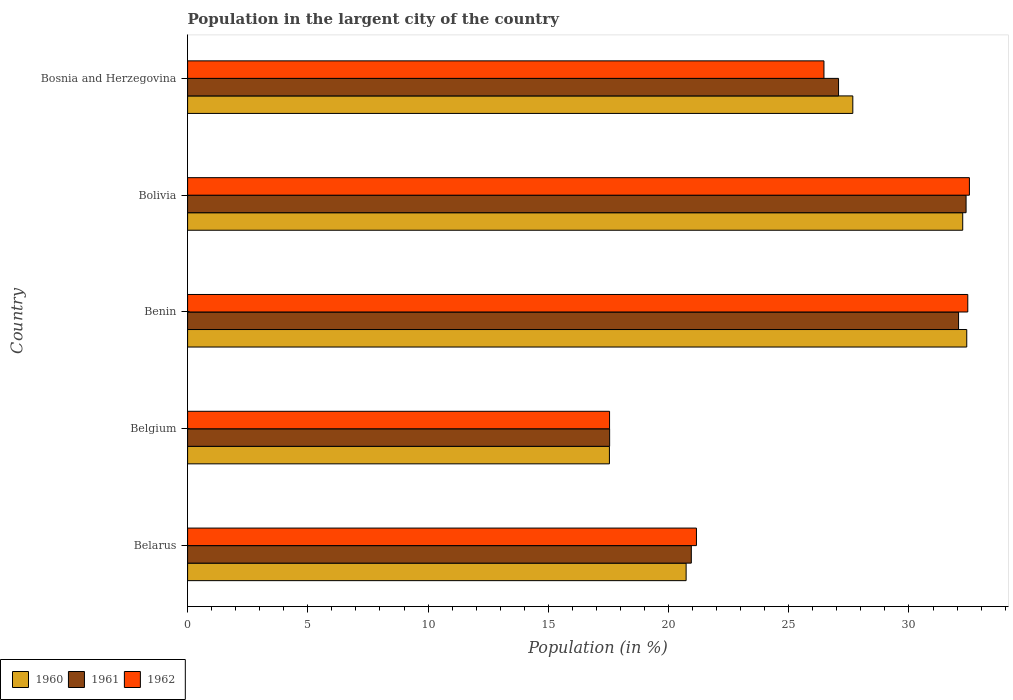How many groups of bars are there?
Provide a short and direct response. 5. Are the number of bars on each tick of the Y-axis equal?
Ensure brevity in your answer.  Yes. What is the label of the 4th group of bars from the top?
Make the answer very short. Belgium. In how many cases, is the number of bars for a given country not equal to the number of legend labels?
Provide a succinct answer. 0. What is the percentage of population in the largent city in 1960 in Belarus?
Provide a short and direct response. 20.73. Across all countries, what is the maximum percentage of population in the largent city in 1962?
Provide a short and direct response. 32.51. Across all countries, what is the minimum percentage of population in the largent city in 1960?
Your response must be concise. 17.54. In which country was the percentage of population in the largent city in 1961 minimum?
Give a very brief answer. Belgium. What is the total percentage of population in the largent city in 1960 in the graph?
Your answer should be very brief. 130.58. What is the difference between the percentage of population in the largent city in 1962 in Belgium and that in Bolivia?
Provide a short and direct response. -14.96. What is the difference between the percentage of population in the largent city in 1960 in Bosnia and Herzegovina and the percentage of population in the largent city in 1961 in Belgium?
Provide a short and direct response. 10.11. What is the average percentage of population in the largent city in 1960 per country?
Your answer should be compact. 26.12. What is the difference between the percentage of population in the largent city in 1960 and percentage of population in the largent city in 1962 in Belarus?
Your response must be concise. -0.43. In how many countries, is the percentage of population in the largent city in 1960 greater than 32 %?
Provide a short and direct response. 2. What is the ratio of the percentage of population in the largent city in 1962 in Benin to that in Bosnia and Herzegovina?
Your answer should be very brief. 1.23. What is the difference between the highest and the second highest percentage of population in the largent city in 1960?
Provide a short and direct response. 0.17. What is the difference between the highest and the lowest percentage of population in the largent city in 1962?
Ensure brevity in your answer.  14.96. In how many countries, is the percentage of population in the largent city in 1962 greater than the average percentage of population in the largent city in 1962 taken over all countries?
Provide a short and direct response. 3. What does the 2nd bar from the top in Bosnia and Herzegovina represents?
Keep it short and to the point. 1961. How many bars are there?
Ensure brevity in your answer.  15. Are all the bars in the graph horizontal?
Offer a terse response. Yes. How many countries are there in the graph?
Your answer should be very brief. 5. Does the graph contain grids?
Offer a terse response. No. Where does the legend appear in the graph?
Make the answer very short. Bottom left. How many legend labels are there?
Provide a short and direct response. 3. How are the legend labels stacked?
Ensure brevity in your answer.  Horizontal. What is the title of the graph?
Make the answer very short. Population in the largent city of the country. What is the label or title of the X-axis?
Your response must be concise. Population (in %). What is the label or title of the Y-axis?
Provide a short and direct response. Country. What is the Population (in %) of 1960 in Belarus?
Make the answer very short. 20.73. What is the Population (in %) of 1961 in Belarus?
Your answer should be very brief. 20.95. What is the Population (in %) in 1962 in Belarus?
Give a very brief answer. 21.16. What is the Population (in %) of 1960 in Belgium?
Make the answer very short. 17.54. What is the Population (in %) of 1961 in Belgium?
Ensure brevity in your answer.  17.55. What is the Population (in %) of 1962 in Belgium?
Make the answer very short. 17.55. What is the Population (in %) of 1960 in Benin?
Make the answer very short. 32.4. What is the Population (in %) in 1961 in Benin?
Provide a short and direct response. 32.06. What is the Population (in %) in 1962 in Benin?
Ensure brevity in your answer.  32.45. What is the Population (in %) of 1960 in Bolivia?
Your answer should be very brief. 32.24. What is the Population (in %) in 1961 in Bolivia?
Give a very brief answer. 32.37. What is the Population (in %) in 1962 in Bolivia?
Your answer should be compact. 32.51. What is the Population (in %) in 1960 in Bosnia and Herzegovina?
Your answer should be compact. 27.66. What is the Population (in %) in 1961 in Bosnia and Herzegovina?
Your answer should be very brief. 27.07. What is the Population (in %) of 1962 in Bosnia and Herzegovina?
Keep it short and to the point. 26.46. Across all countries, what is the maximum Population (in %) in 1960?
Provide a short and direct response. 32.4. Across all countries, what is the maximum Population (in %) of 1961?
Your answer should be compact. 32.37. Across all countries, what is the maximum Population (in %) in 1962?
Provide a succinct answer. 32.51. Across all countries, what is the minimum Population (in %) in 1960?
Keep it short and to the point. 17.54. Across all countries, what is the minimum Population (in %) in 1961?
Ensure brevity in your answer.  17.55. Across all countries, what is the minimum Population (in %) of 1962?
Provide a short and direct response. 17.55. What is the total Population (in %) in 1960 in the graph?
Keep it short and to the point. 130.58. What is the total Population (in %) in 1961 in the graph?
Provide a short and direct response. 130.01. What is the total Population (in %) in 1962 in the graph?
Your answer should be compact. 130.13. What is the difference between the Population (in %) in 1960 in Belarus and that in Belgium?
Your answer should be compact. 3.19. What is the difference between the Population (in %) of 1961 in Belarus and that in Belgium?
Your answer should be very brief. 3.4. What is the difference between the Population (in %) in 1962 in Belarus and that in Belgium?
Your response must be concise. 3.61. What is the difference between the Population (in %) in 1960 in Belarus and that in Benin?
Provide a short and direct response. -11.67. What is the difference between the Population (in %) in 1961 in Belarus and that in Benin?
Ensure brevity in your answer.  -11.11. What is the difference between the Population (in %) of 1962 in Belarus and that in Benin?
Your response must be concise. -11.28. What is the difference between the Population (in %) in 1960 in Belarus and that in Bolivia?
Offer a very short reply. -11.5. What is the difference between the Population (in %) in 1961 in Belarus and that in Bolivia?
Your response must be concise. -11.43. What is the difference between the Population (in %) of 1962 in Belarus and that in Bolivia?
Your answer should be compact. -11.35. What is the difference between the Population (in %) in 1960 in Belarus and that in Bosnia and Herzegovina?
Provide a short and direct response. -6.93. What is the difference between the Population (in %) of 1961 in Belarus and that in Bosnia and Herzegovina?
Keep it short and to the point. -6.12. What is the difference between the Population (in %) of 1962 in Belarus and that in Bosnia and Herzegovina?
Offer a terse response. -5.3. What is the difference between the Population (in %) in 1960 in Belgium and that in Benin?
Provide a succinct answer. -14.86. What is the difference between the Population (in %) of 1961 in Belgium and that in Benin?
Provide a succinct answer. -14.51. What is the difference between the Population (in %) of 1962 in Belgium and that in Benin?
Your answer should be very brief. -14.9. What is the difference between the Population (in %) in 1960 in Belgium and that in Bolivia?
Provide a short and direct response. -14.69. What is the difference between the Population (in %) in 1961 in Belgium and that in Bolivia?
Ensure brevity in your answer.  -14.82. What is the difference between the Population (in %) in 1962 in Belgium and that in Bolivia?
Keep it short and to the point. -14.96. What is the difference between the Population (in %) in 1960 in Belgium and that in Bosnia and Herzegovina?
Ensure brevity in your answer.  -10.12. What is the difference between the Population (in %) in 1961 in Belgium and that in Bosnia and Herzegovina?
Your response must be concise. -9.52. What is the difference between the Population (in %) of 1962 in Belgium and that in Bosnia and Herzegovina?
Offer a terse response. -8.92. What is the difference between the Population (in %) of 1960 in Benin and that in Bolivia?
Offer a terse response. 0.17. What is the difference between the Population (in %) in 1961 in Benin and that in Bolivia?
Provide a succinct answer. -0.31. What is the difference between the Population (in %) of 1962 in Benin and that in Bolivia?
Provide a succinct answer. -0.07. What is the difference between the Population (in %) in 1960 in Benin and that in Bosnia and Herzegovina?
Make the answer very short. 4.74. What is the difference between the Population (in %) in 1961 in Benin and that in Bosnia and Herzegovina?
Give a very brief answer. 4.99. What is the difference between the Population (in %) in 1962 in Benin and that in Bosnia and Herzegovina?
Your response must be concise. 5.98. What is the difference between the Population (in %) of 1960 in Bolivia and that in Bosnia and Herzegovina?
Provide a short and direct response. 4.57. What is the difference between the Population (in %) in 1961 in Bolivia and that in Bosnia and Herzegovina?
Provide a succinct answer. 5.3. What is the difference between the Population (in %) in 1962 in Bolivia and that in Bosnia and Herzegovina?
Ensure brevity in your answer.  6.05. What is the difference between the Population (in %) of 1960 in Belarus and the Population (in %) of 1961 in Belgium?
Your response must be concise. 3.18. What is the difference between the Population (in %) of 1960 in Belarus and the Population (in %) of 1962 in Belgium?
Offer a terse response. 3.18. What is the difference between the Population (in %) in 1961 in Belarus and the Population (in %) in 1962 in Belgium?
Keep it short and to the point. 3.4. What is the difference between the Population (in %) of 1960 in Belarus and the Population (in %) of 1961 in Benin?
Provide a succinct answer. -11.33. What is the difference between the Population (in %) in 1960 in Belarus and the Population (in %) in 1962 in Benin?
Your response must be concise. -11.71. What is the difference between the Population (in %) of 1961 in Belarus and the Population (in %) of 1962 in Benin?
Make the answer very short. -11.5. What is the difference between the Population (in %) in 1960 in Belarus and the Population (in %) in 1961 in Bolivia?
Your answer should be very brief. -11.64. What is the difference between the Population (in %) of 1960 in Belarus and the Population (in %) of 1962 in Bolivia?
Make the answer very short. -11.78. What is the difference between the Population (in %) of 1961 in Belarus and the Population (in %) of 1962 in Bolivia?
Keep it short and to the point. -11.56. What is the difference between the Population (in %) in 1960 in Belarus and the Population (in %) in 1961 in Bosnia and Herzegovina?
Give a very brief answer. -6.34. What is the difference between the Population (in %) in 1960 in Belarus and the Population (in %) in 1962 in Bosnia and Herzegovina?
Keep it short and to the point. -5.73. What is the difference between the Population (in %) of 1961 in Belarus and the Population (in %) of 1962 in Bosnia and Herzegovina?
Provide a succinct answer. -5.52. What is the difference between the Population (in %) in 1960 in Belgium and the Population (in %) in 1961 in Benin?
Your answer should be very brief. -14.52. What is the difference between the Population (in %) in 1960 in Belgium and the Population (in %) in 1962 in Benin?
Offer a very short reply. -14.9. What is the difference between the Population (in %) of 1961 in Belgium and the Population (in %) of 1962 in Benin?
Keep it short and to the point. -14.89. What is the difference between the Population (in %) of 1960 in Belgium and the Population (in %) of 1961 in Bolivia?
Provide a succinct answer. -14.83. What is the difference between the Population (in %) in 1960 in Belgium and the Population (in %) in 1962 in Bolivia?
Your answer should be very brief. -14.97. What is the difference between the Population (in %) in 1961 in Belgium and the Population (in %) in 1962 in Bolivia?
Your answer should be very brief. -14.96. What is the difference between the Population (in %) of 1960 in Belgium and the Population (in %) of 1961 in Bosnia and Herzegovina?
Provide a short and direct response. -9.53. What is the difference between the Population (in %) of 1960 in Belgium and the Population (in %) of 1962 in Bosnia and Herzegovina?
Ensure brevity in your answer.  -8.92. What is the difference between the Population (in %) in 1961 in Belgium and the Population (in %) in 1962 in Bosnia and Herzegovina?
Offer a terse response. -8.91. What is the difference between the Population (in %) of 1960 in Benin and the Population (in %) of 1961 in Bolivia?
Your answer should be compact. 0.03. What is the difference between the Population (in %) of 1960 in Benin and the Population (in %) of 1962 in Bolivia?
Provide a short and direct response. -0.11. What is the difference between the Population (in %) of 1961 in Benin and the Population (in %) of 1962 in Bolivia?
Your response must be concise. -0.45. What is the difference between the Population (in %) in 1960 in Benin and the Population (in %) in 1961 in Bosnia and Herzegovina?
Your answer should be very brief. 5.33. What is the difference between the Population (in %) of 1960 in Benin and the Population (in %) of 1962 in Bosnia and Herzegovina?
Provide a succinct answer. 5.94. What is the difference between the Population (in %) of 1961 in Benin and the Population (in %) of 1962 in Bosnia and Herzegovina?
Your answer should be compact. 5.6. What is the difference between the Population (in %) of 1960 in Bolivia and the Population (in %) of 1961 in Bosnia and Herzegovina?
Keep it short and to the point. 5.16. What is the difference between the Population (in %) in 1960 in Bolivia and the Population (in %) in 1962 in Bosnia and Herzegovina?
Make the answer very short. 5.77. What is the difference between the Population (in %) of 1961 in Bolivia and the Population (in %) of 1962 in Bosnia and Herzegovina?
Your answer should be compact. 5.91. What is the average Population (in %) of 1960 per country?
Make the answer very short. 26.12. What is the average Population (in %) of 1961 per country?
Provide a succinct answer. 26. What is the average Population (in %) of 1962 per country?
Your answer should be very brief. 26.03. What is the difference between the Population (in %) in 1960 and Population (in %) in 1961 in Belarus?
Offer a very short reply. -0.22. What is the difference between the Population (in %) in 1960 and Population (in %) in 1962 in Belarus?
Offer a terse response. -0.43. What is the difference between the Population (in %) of 1961 and Population (in %) of 1962 in Belarus?
Offer a very short reply. -0.21. What is the difference between the Population (in %) in 1960 and Population (in %) in 1961 in Belgium?
Your answer should be compact. -0.01. What is the difference between the Population (in %) of 1960 and Population (in %) of 1962 in Belgium?
Ensure brevity in your answer.  -0.01. What is the difference between the Population (in %) in 1961 and Population (in %) in 1962 in Belgium?
Your answer should be compact. 0. What is the difference between the Population (in %) of 1960 and Population (in %) of 1961 in Benin?
Ensure brevity in your answer.  0.34. What is the difference between the Population (in %) of 1960 and Population (in %) of 1962 in Benin?
Your answer should be compact. -0.04. What is the difference between the Population (in %) of 1961 and Population (in %) of 1962 in Benin?
Provide a short and direct response. -0.38. What is the difference between the Population (in %) of 1960 and Population (in %) of 1961 in Bolivia?
Provide a succinct answer. -0.14. What is the difference between the Population (in %) of 1960 and Population (in %) of 1962 in Bolivia?
Keep it short and to the point. -0.28. What is the difference between the Population (in %) in 1961 and Population (in %) in 1962 in Bolivia?
Your answer should be compact. -0.14. What is the difference between the Population (in %) in 1960 and Population (in %) in 1961 in Bosnia and Herzegovina?
Ensure brevity in your answer.  0.59. What is the difference between the Population (in %) in 1960 and Population (in %) in 1962 in Bosnia and Herzegovina?
Your answer should be compact. 1.2. What is the difference between the Population (in %) in 1961 and Population (in %) in 1962 in Bosnia and Herzegovina?
Provide a short and direct response. 0.61. What is the ratio of the Population (in %) of 1960 in Belarus to that in Belgium?
Keep it short and to the point. 1.18. What is the ratio of the Population (in %) in 1961 in Belarus to that in Belgium?
Your answer should be compact. 1.19. What is the ratio of the Population (in %) of 1962 in Belarus to that in Belgium?
Offer a very short reply. 1.21. What is the ratio of the Population (in %) of 1960 in Belarus to that in Benin?
Provide a succinct answer. 0.64. What is the ratio of the Population (in %) in 1961 in Belarus to that in Benin?
Your answer should be compact. 0.65. What is the ratio of the Population (in %) of 1962 in Belarus to that in Benin?
Provide a short and direct response. 0.65. What is the ratio of the Population (in %) in 1960 in Belarus to that in Bolivia?
Offer a very short reply. 0.64. What is the ratio of the Population (in %) in 1961 in Belarus to that in Bolivia?
Give a very brief answer. 0.65. What is the ratio of the Population (in %) in 1962 in Belarus to that in Bolivia?
Make the answer very short. 0.65. What is the ratio of the Population (in %) of 1960 in Belarus to that in Bosnia and Herzegovina?
Give a very brief answer. 0.75. What is the ratio of the Population (in %) in 1961 in Belarus to that in Bosnia and Herzegovina?
Give a very brief answer. 0.77. What is the ratio of the Population (in %) of 1962 in Belarus to that in Bosnia and Herzegovina?
Offer a terse response. 0.8. What is the ratio of the Population (in %) in 1960 in Belgium to that in Benin?
Keep it short and to the point. 0.54. What is the ratio of the Population (in %) in 1961 in Belgium to that in Benin?
Provide a succinct answer. 0.55. What is the ratio of the Population (in %) of 1962 in Belgium to that in Benin?
Offer a very short reply. 0.54. What is the ratio of the Population (in %) of 1960 in Belgium to that in Bolivia?
Offer a terse response. 0.54. What is the ratio of the Population (in %) of 1961 in Belgium to that in Bolivia?
Provide a succinct answer. 0.54. What is the ratio of the Population (in %) of 1962 in Belgium to that in Bolivia?
Your response must be concise. 0.54. What is the ratio of the Population (in %) in 1960 in Belgium to that in Bosnia and Herzegovina?
Ensure brevity in your answer.  0.63. What is the ratio of the Population (in %) of 1961 in Belgium to that in Bosnia and Herzegovina?
Make the answer very short. 0.65. What is the ratio of the Population (in %) of 1962 in Belgium to that in Bosnia and Herzegovina?
Provide a succinct answer. 0.66. What is the ratio of the Population (in %) of 1962 in Benin to that in Bolivia?
Ensure brevity in your answer.  1. What is the ratio of the Population (in %) of 1960 in Benin to that in Bosnia and Herzegovina?
Give a very brief answer. 1.17. What is the ratio of the Population (in %) in 1961 in Benin to that in Bosnia and Herzegovina?
Offer a very short reply. 1.18. What is the ratio of the Population (in %) in 1962 in Benin to that in Bosnia and Herzegovina?
Keep it short and to the point. 1.23. What is the ratio of the Population (in %) of 1960 in Bolivia to that in Bosnia and Herzegovina?
Give a very brief answer. 1.17. What is the ratio of the Population (in %) in 1961 in Bolivia to that in Bosnia and Herzegovina?
Provide a succinct answer. 1.2. What is the ratio of the Population (in %) in 1962 in Bolivia to that in Bosnia and Herzegovina?
Keep it short and to the point. 1.23. What is the difference between the highest and the second highest Population (in %) in 1960?
Provide a short and direct response. 0.17. What is the difference between the highest and the second highest Population (in %) in 1961?
Ensure brevity in your answer.  0.31. What is the difference between the highest and the second highest Population (in %) of 1962?
Provide a short and direct response. 0.07. What is the difference between the highest and the lowest Population (in %) in 1960?
Make the answer very short. 14.86. What is the difference between the highest and the lowest Population (in %) of 1961?
Give a very brief answer. 14.82. What is the difference between the highest and the lowest Population (in %) of 1962?
Your answer should be compact. 14.96. 